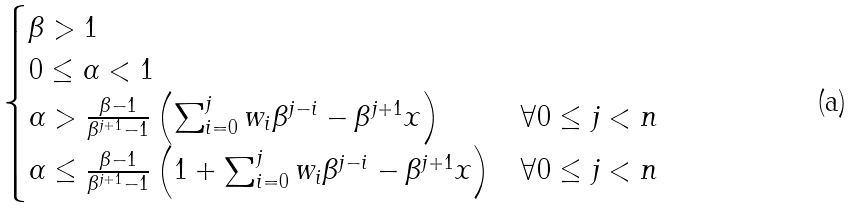<formula> <loc_0><loc_0><loc_500><loc_500>\begin{cases} \beta > 1 \\ 0 \leq \alpha < 1 \\ \alpha > \frac { \beta - 1 } { \beta ^ { j + 1 } - 1 } \left ( \sum _ { i = 0 } ^ { j } w _ { i } \beta ^ { j - i } - \beta ^ { j + 1 } x \right ) & \forall 0 \leq j < n \\ \alpha \leq \frac { \beta - 1 } { \beta ^ { j + 1 } - 1 } \left ( 1 + \sum _ { i = 0 } ^ { j } w _ { i } \beta ^ { j - i } - \beta ^ { j + 1 } x \right ) & \forall 0 \leq j < n \end{cases}</formula> 